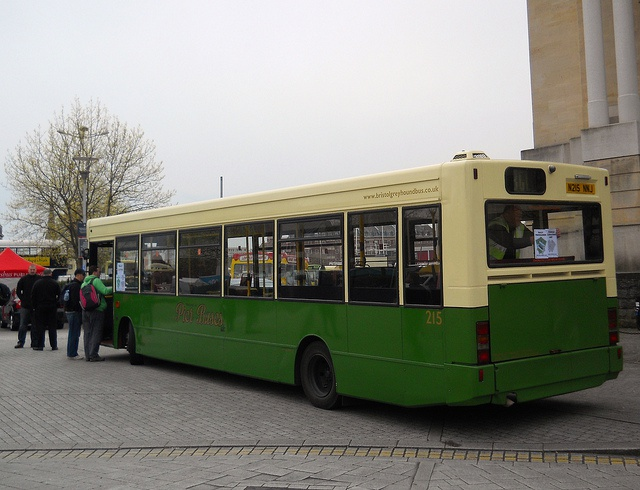Describe the objects in this image and their specific colors. I can see bus in lightgray, black, darkgreen, tan, and gray tones, people in lightgray, black, green, maroon, and darkgreen tones, people in lightgray, black, darkgreen, and gray tones, people in lightgray, black, gray, and maroon tones, and people in lightgray, black, gray, and maroon tones in this image. 